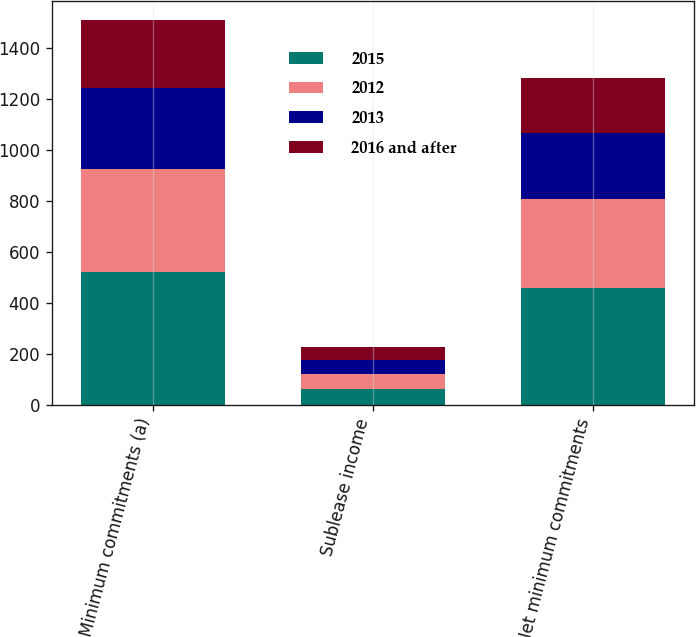Convert chart. <chart><loc_0><loc_0><loc_500><loc_500><stacked_bar_chart><ecel><fcel>Minimum commitments (a)<fcel>Sublease income<fcel>Net minimum commitments<nl><fcel>2015<fcel>520<fcel>60<fcel>460<nl><fcel>2012<fcel>406<fcel>60<fcel>346<nl><fcel>2013<fcel>318<fcel>55<fcel>263<nl><fcel>2016 and after<fcel>266<fcel>51<fcel>215<nl></chart> 